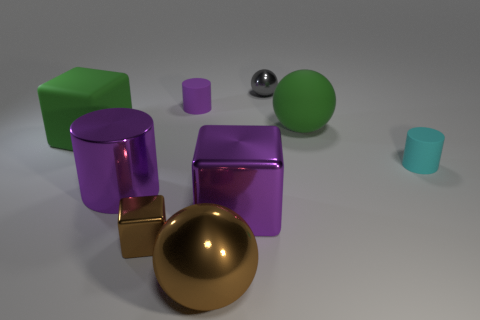Subtract all big purple metal cylinders. How many cylinders are left? 2 Subtract all brown cubes. How many cubes are left? 2 Add 1 tiny cyan cylinders. How many objects exist? 10 Subtract all brown cubes. How many purple cylinders are left? 2 Subtract all cylinders. How many objects are left? 6 Subtract 1 blocks. How many blocks are left? 2 Subtract all large blue rubber objects. Subtract all big brown metal things. How many objects are left? 8 Add 6 brown objects. How many brown objects are left? 8 Add 7 big green matte cylinders. How many big green matte cylinders exist? 7 Subtract 1 brown spheres. How many objects are left? 8 